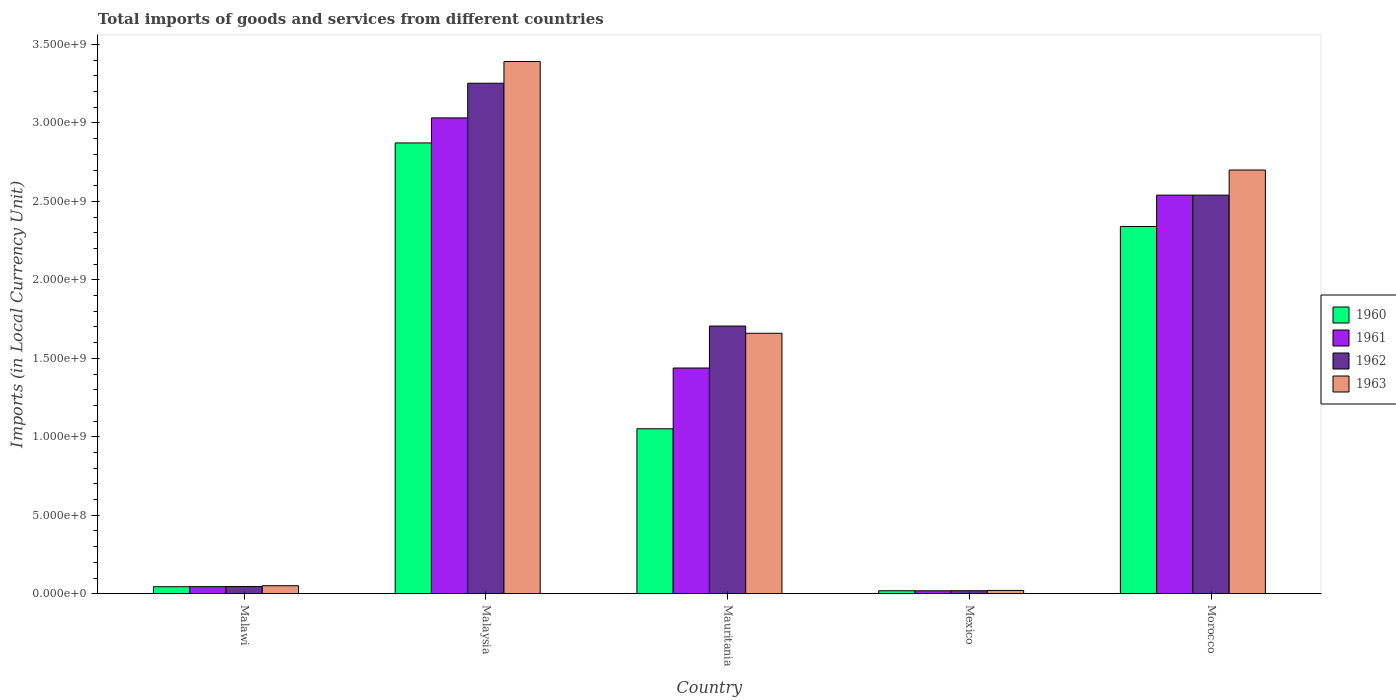What is the label of the 5th group of bars from the left?
Provide a succinct answer. Morocco. What is the Amount of goods and services imports in 1962 in Malawi?
Keep it short and to the point. 4.58e+07. Across all countries, what is the maximum Amount of goods and services imports in 1961?
Your answer should be compact. 3.03e+09. Across all countries, what is the minimum Amount of goods and services imports in 1963?
Give a very brief answer. 2.11e+07. In which country was the Amount of goods and services imports in 1960 maximum?
Your answer should be very brief. Malaysia. In which country was the Amount of goods and services imports in 1963 minimum?
Provide a succinct answer. Mexico. What is the total Amount of goods and services imports in 1960 in the graph?
Keep it short and to the point. 6.33e+09. What is the difference between the Amount of goods and services imports in 1961 in Mexico and that in Morocco?
Keep it short and to the point. -2.52e+09. What is the difference between the Amount of goods and services imports in 1960 in Malaysia and the Amount of goods and services imports in 1962 in Morocco?
Give a very brief answer. 3.33e+08. What is the average Amount of goods and services imports in 1961 per country?
Provide a succinct answer. 1.41e+09. What is the difference between the Amount of goods and services imports of/in 1961 and Amount of goods and services imports of/in 1960 in Malawi?
Keep it short and to the point. 4.00e+05. What is the ratio of the Amount of goods and services imports in 1960 in Malawi to that in Morocco?
Make the answer very short. 0.02. What is the difference between the highest and the second highest Amount of goods and services imports in 1962?
Ensure brevity in your answer.  7.13e+08. What is the difference between the highest and the lowest Amount of goods and services imports in 1963?
Ensure brevity in your answer.  3.37e+09. In how many countries, is the Amount of goods and services imports in 1960 greater than the average Amount of goods and services imports in 1960 taken over all countries?
Give a very brief answer. 2. Is the sum of the Amount of goods and services imports in 1962 in Malaysia and Morocco greater than the maximum Amount of goods and services imports in 1961 across all countries?
Offer a very short reply. Yes. Is it the case that in every country, the sum of the Amount of goods and services imports in 1960 and Amount of goods and services imports in 1963 is greater than the sum of Amount of goods and services imports in 1962 and Amount of goods and services imports in 1961?
Offer a terse response. No. What does the 1st bar from the right in Malaysia represents?
Make the answer very short. 1963. Is it the case that in every country, the sum of the Amount of goods and services imports in 1960 and Amount of goods and services imports in 1963 is greater than the Amount of goods and services imports in 1962?
Make the answer very short. Yes. Are the values on the major ticks of Y-axis written in scientific E-notation?
Keep it short and to the point. Yes. Where does the legend appear in the graph?
Give a very brief answer. Center right. How are the legend labels stacked?
Keep it short and to the point. Vertical. What is the title of the graph?
Keep it short and to the point. Total imports of goods and services from different countries. What is the label or title of the Y-axis?
Give a very brief answer. Imports (in Local Currency Unit). What is the Imports (in Local Currency Unit) of 1960 in Malawi?
Your response must be concise. 4.47e+07. What is the Imports (in Local Currency Unit) in 1961 in Malawi?
Offer a terse response. 4.51e+07. What is the Imports (in Local Currency Unit) of 1962 in Malawi?
Give a very brief answer. 4.58e+07. What is the Imports (in Local Currency Unit) of 1963 in Malawi?
Your response must be concise. 5.11e+07. What is the Imports (in Local Currency Unit) of 1960 in Malaysia?
Keep it short and to the point. 2.87e+09. What is the Imports (in Local Currency Unit) of 1961 in Malaysia?
Ensure brevity in your answer.  3.03e+09. What is the Imports (in Local Currency Unit) in 1962 in Malaysia?
Make the answer very short. 3.25e+09. What is the Imports (in Local Currency Unit) of 1963 in Malaysia?
Offer a very short reply. 3.39e+09. What is the Imports (in Local Currency Unit) of 1960 in Mauritania?
Your response must be concise. 1.05e+09. What is the Imports (in Local Currency Unit) in 1961 in Mauritania?
Make the answer very short. 1.44e+09. What is the Imports (in Local Currency Unit) in 1962 in Mauritania?
Ensure brevity in your answer.  1.71e+09. What is the Imports (in Local Currency Unit) of 1963 in Mauritania?
Offer a terse response. 1.66e+09. What is the Imports (in Local Currency Unit) in 1960 in Mexico?
Your answer should be very brief. 1.90e+07. What is the Imports (in Local Currency Unit) of 1961 in Mexico?
Your response must be concise. 1.88e+07. What is the Imports (in Local Currency Unit) in 1962 in Mexico?
Give a very brief answer. 1.92e+07. What is the Imports (in Local Currency Unit) of 1963 in Mexico?
Make the answer very short. 2.11e+07. What is the Imports (in Local Currency Unit) of 1960 in Morocco?
Give a very brief answer. 2.34e+09. What is the Imports (in Local Currency Unit) in 1961 in Morocco?
Offer a very short reply. 2.54e+09. What is the Imports (in Local Currency Unit) of 1962 in Morocco?
Provide a short and direct response. 2.54e+09. What is the Imports (in Local Currency Unit) of 1963 in Morocco?
Keep it short and to the point. 2.70e+09. Across all countries, what is the maximum Imports (in Local Currency Unit) in 1960?
Make the answer very short. 2.87e+09. Across all countries, what is the maximum Imports (in Local Currency Unit) in 1961?
Your answer should be very brief. 3.03e+09. Across all countries, what is the maximum Imports (in Local Currency Unit) in 1962?
Your answer should be compact. 3.25e+09. Across all countries, what is the maximum Imports (in Local Currency Unit) in 1963?
Your answer should be very brief. 3.39e+09. Across all countries, what is the minimum Imports (in Local Currency Unit) of 1960?
Give a very brief answer. 1.90e+07. Across all countries, what is the minimum Imports (in Local Currency Unit) of 1961?
Keep it short and to the point. 1.88e+07. Across all countries, what is the minimum Imports (in Local Currency Unit) in 1962?
Ensure brevity in your answer.  1.92e+07. Across all countries, what is the minimum Imports (in Local Currency Unit) of 1963?
Provide a short and direct response. 2.11e+07. What is the total Imports (in Local Currency Unit) in 1960 in the graph?
Your answer should be very brief. 6.33e+09. What is the total Imports (in Local Currency Unit) in 1961 in the graph?
Offer a terse response. 7.07e+09. What is the total Imports (in Local Currency Unit) of 1962 in the graph?
Ensure brevity in your answer.  7.56e+09. What is the total Imports (in Local Currency Unit) of 1963 in the graph?
Give a very brief answer. 7.82e+09. What is the difference between the Imports (in Local Currency Unit) of 1960 in Malawi and that in Malaysia?
Your response must be concise. -2.83e+09. What is the difference between the Imports (in Local Currency Unit) in 1961 in Malawi and that in Malaysia?
Provide a succinct answer. -2.99e+09. What is the difference between the Imports (in Local Currency Unit) in 1962 in Malawi and that in Malaysia?
Your answer should be compact. -3.21e+09. What is the difference between the Imports (in Local Currency Unit) of 1963 in Malawi and that in Malaysia?
Your response must be concise. -3.34e+09. What is the difference between the Imports (in Local Currency Unit) in 1960 in Malawi and that in Mauritania?
Give a very brief answer. -1.01e+09. What is the difference between the Imports (in Local Currency Unit) in 1961 in Malawi and that in Mauritania?
Offer a terse response. -1.39e+09. What is the difference between the Imports (in Local Currency Unit) of 1962 in Malawi and that in Mauritania?
Your answer should be compact. -1.66e+09. What is the difference between the Imports (in Local Currency Unit) in 1963 in Malawi and that in Mauritania?
Give a very brief answer. -1.61e+09. What is the difference between the Imports (in Local Currency Unit) of 1960 in Malawi and that in Mexico?
Make the answer very short. 2.57e+07. What is the difference between the Imports (in Local Currency Unit) of 1961 in Malawi and that in Mexico?
Provide a succinct answer. 2.63e+07. What is the difference between the Imports (in Local Currency Unit) of 1962 in Malawi and that in Mexico?
Provide a succinct answer. 2.66e+07. What is the difference between the Imports (in Local Currency Unit) in 1963 in Malawi and that in Mexico?
Your answer should be very brief. 3.00e+07. What is the difference between the Imports (in Local Currency Unit) in 1960 in Malawi and that in Morocco?
Ensure brevity in your answer.  -2.30e+09. What is the difference between the Imports (in Local Currency Unit) of 1961 in Malawi and that in Morocco?
Ensure brevity in your answer.  -2.49e+09. What is the difference between the Imports (in Local Currency Unit) of 1962 in Malawi and that in Morocco?
Provide a short and direct response. -2.49e+09. What is the difference between the Imports (in Local Currency Unit) of 1963 in Malawi and that in Morocco?
Ensure brevity in your answer.  -2.65e+09. What is the difference between the Imports (in Local Currency Unit) of 1960 in Malaysia and that in Mauritania?
Your response must be concise. 1.82e+09. What is the difference between the Imports (in Local Currency Unit) in 1961 in Malaysia and that in Mauritania?
Give a very brief answer. 1.59e+09. What is the difference between the Imports (in Local Currency Unit) in 1962 in Malaysia and that in Mauritania?
Give a very brief answer. 1.55e+09. What is the difference between the Imports (in Local Currency Unit) in 1963 in Malaysia and that in Mauritania?
Keep it short and to the point. 1.73e+09. What is the difference between the Imports (in Local Currency Unit) in 1960 in Malaysia and that in Mexico?
Offer a terse response. 2.85e+09. What is the difference between the Imports (in Local Currency Unit) in 1961 in Malaysia and that in Mexico?
Make the answer very short. 3.01e+09. What is the difference between the Imports (in Local Currency Unit) in 1962 in Malaysia and that in Mexico?
Your answer should be compact. 3.23e+09. What is the difference between the Imports (in Local Currency Unit) in 1963 in Malaysia and that in Mexico?
Offer a very short reply. 3.37e+09. What is the difference between the Imports (in Local Currency Unit) of 1960 in Malaysia and that in Morocco?
Offer a terse response. 5.33e+08. What is the difference between the Imports (in Local Currency Unit) of 1961 in Malaysia and that in Morocco?
Give a very brief answer. 4.92e+08. What is the difference between the Imports (in Local Currency Unit) of 1962 in Malaysia and that in Morocco?
Provide a succinct answer. 7.13e+08. What is the difference between the Imports (in Local Currency Unit) of 1963 in Malaysia and that in Morocco?
Your answer should be compact. 6.92e+08. What is the difference between the Imports (in Local Currency Unit) of 1960 in Mauritania and that in Mexico?
Give a very brief answer. 1.03e+09. What is the difference between the Imports (in Local Currency Unit) in 1961 in Mauritania and that in Mexico?
Provide a succinct answer. 1.42e+09. What is the difference between the Imports (in Local Currency Unit) in 1962 in Mauritania and that in Mexico?
Your response must be concise. 1.69e+09. What is the difference between the Imports (in Local Currency Unit) of 1963 in Mauritania and that in Mexico?
Offer a very short reply. 1.64e+09. What is the difference between the Imports (in Local Currency Unit) in 1960 in Mauritania and that in Morocco?
Keep it short and to the point. -1.29e+09. What is the difference between the Imports (in Local Currency Unit) of 1961 in Mauritania and that in Morocco?
Your answer should be compact. -1.10e+09. What is the difference between the Imports (in Local Currency Unit) in 1962 in Mauritania and that in Morocco?
Provide a short and direct response. -8.34e+08. What is the difference between the Imports (in Local Currency Unit) in 1963 in Mauritania and that in Morocco?
Make the answer very short. -1.04e+09. What is the difference between the Imports (in Local Currency Unit) in 1960 in Mexico and that in Morocco?
Your answer should be very brief. -2.32e+09. What is the difference between the Imports (in Local Currency Unit) of 1961 in Mexico and that in Morocco?
Offer a very short reply. -2.52e+09. What is the difference between the Imports (in Local Currency Unit) in 1962 in Mexico and that in Morocco?
Offer a terse response. -2.52e+09. What is the difference between the Imports (in Local Currency Unit) in 1963 in Mexico and that in Morocco?
Your answer should be compact. -2.68e+09. What is the difference between the Imports (in Local Currency Unit) of 1960 in Malawi and the Imports (in Local Currency Unit) of 1961 in Malaysia?
Your response must be concise. -2.99e+09. What is the difference between the Imports (in Local Currency Unit) in 1960 in Malawi and the Imports (in Local Currency Unit) in 1962 in Malaysia?
Offer a terse response. -3.21e+09. What is the difference between the Imports (in Local Currency Unit) of 1960 in Malawi and the Imports (in Local Currency Unit) of 1963 in Malaysia?
Give a very brief answer. -3.35e+09. What is the difference between the Imports (in Local Currency Unit) in 1961 in Malawi and the Imports (in Local Currency Unit) in 1962 in Malaysia?
Give a very brief answer. -3.21e+09. What is the difference between the Imports (in Local Currency Unit) of 1961 in Malawi and the Imports (in Local Currency Unit) of 1963 in Malaysia?
Your answer should be very brief. -3.35e+09. What is the difference between the Imports (in Local Currency Unit) in 1962 in Malawi and the Imports (in Local Currency Unit) in 1963 in Malaysia?
Your response must be concise. -3.35e+09. What is the difference between the Imports (in Local Currency Unit) of 1960 in Malawi and the Imports (in Local Currency Unit) of 1961 in Mauritania?
Offer a terse response. -1.39e+09. What is the difference between the Imports (in Local Currency Unit) in 1960 in Malawi and the Imports (in Local Currency Unit) in 1962 in Mauritania?
Make the answer very short. -1.66e+09. What is the difference between the Imports (in Local Currency Unit) of 1960 in Malawi and the Imports (in Local Currency Unit) of 1963 in Mauritania?
Keep it short and to the point. -1.62e+09. What is the difference between the Imports (in Local Currency Unit) in 1961 in Malawi and the Imports (in Local Currency Unit) in 1962 in Mauritania?
Offer a terse response. -1.66e+09. What is the difference between the Imports (in Local Currency Unit) of 1961 in Malawi and the Imports (in Local Currency Unit) of 1963 in Mauritania?
Keep it short and to the point. -1.61e+09. What is the difference between the Imports (in Local Currency Unit) in 1962 in Malawi and the Imports (in Local Currency Unit) in 1963 in Mauritania?
Offer a very short reply. -1.61e+09. What is the difference between the Imports (in Local Currency Unit) in 1960 in Malawi and the Imports (in Local Currency Unit) in 1961 in Mexico?
Your answer should be very brief. 2.59e+07. What is the difference between the Imports (in Local Currency Unit) in 1960 in Malawi and the Imports (in Local Currency Unit) in 1962 in Mexico?
Your answer should be very brief. 2.55e+07. What is the difference between the Imports (in Local Currency Unit) in 1960 in Malawi and the Imports (in Local Currency Unit) in 1963 in Mexico?
Keep it short and to the point. 2.36e+07. What is the difference between the Imports (in Local Currency Unit) in 1961 in Malawi and the Imports (in Local Currency Unit) in 1962 in Mexico?
Provide a succinct answer. 2.59e+07. What is the difference between the Imports (in Local Currency Unit) in 1961 in Malawi and the Imports (in Local Currency Unit) in 1963 in Mexico?
Provide a succinct answer. 2.40e+07. What is the difference between the Imports (in Local Currency Unit) of 1962 in Malawi and the Imports (in Local Currency Unit) of 1963 in Mexico?
Your response must be concise. 2.47e+07. What is the difference between the Imports (in Local Currency Unit) in 1960 in Malawi and the Imports (in Local Currency Unit) in 1961 in Morocco?
Ensure brevity in your answer.  -2.50e+09. What is the difference between the Imports (in Local Currency Unit) of 1960 in Malawi and the Imports (in Local Currency Unit) of 1962 in Morocco?
Provide a succinct answer. -2.50e+09. What is the difference between the Imports (in Local Currency Unit) of 1960 in Malawi and the Imports (in Local Currency Unit) of 1963 in Morocco?
Offer a very short reply. -2.66e+09. What is the difference between the Imports (in Local Currency Unit) in 1961 in Malawi and the Imports (in Local Currency Unit) in 1962 in Morocco?
Offer a very short reply. -2.49e+09. What is the difference between the Imports (in Local Currency Unit) of 1961 in Malawi and the Imports (in Local Currency Unit) of 1963 in Morocco?
Give a very brief answer. -2.65e+09. What is the difference between the Imports (in Local Currency Unit) in 1962 in Malawi and the Imports (in Local Currency Unit) in 1963 in Morocco?
Provide a succinct answer. -2.65e+09. What is the difference between the Imports (in Local Currency Unit) of 1960 in Malaysia and the Imports (in Local Currency Unit) of 1961 in Mauritania?
Offer a very short reply. 1.43e+09. What is the difference between the Imports (in Local Currency Unit) of 1960 in Malaysia and the Imports (in Local Currency Unit) of 1962 in Mauritania?
Make the answer very short. 1.17e+09. What is the difference between the Imports (in Local Currency Unit) of 1960 in Malaysia and the Imports (in Local Currency Unit) of 1963 in Mauritania?
Offer a terse response. 1.21e+09. What is the difference between the Imports (in Local Currency Unit) of 1961 in Malaysia and the Imports (in Local Currency Unit) of 1962 in Mauritania?
Ensure brevity in your answer.  1.33e+09. What is the difference between the Imports (in Local Currency Unit) in 1961 in Malaysia and the Imports (in Local Currency Unit) in 1963 in Mauritania?
Your response must be concise. 1.37e+09. What is the difference between the Imports (in Local Currency Unit) of 1962 in Malaysia and the Imports (in Local Currency Unit) of 1963 in Mauritania?
Your answer should be compact. 1.59e+09. What is the difference between the Imports (in Local Currency Unit) of 1960 in Malaysia and the Imports (in Local Currency Unit) of 1961 in Mexico?
Your answer should be compact. 2.85e+09. What is the difference between the Imports (in Local Currency Unit) in 1960 in Malaysia and the Imports (in Local Currency Unit) in 1962 in Mexico?
Offer a very short reply. 2.85e+09. What is the difference between the Imports (in Local Currency Unit) of 1960 in Malaysia and the Imports (in Local Currency Unit) of 1963 in Mexico?
Keep it short and to the point. 2.85e+09. What is the difference between the Imports (in Local Currency Unit) of 1961 in Malaysia and the Imports (in Local Currency Unit) of 1962 in Mexico?
Offer a terse response. 3.01e+09. What is the difference between the Imports (in Local Currency Unit) of 1961 in Malaysia and the Imports (in Local Currency Unit) of 1963 in Mexico?
Make the answer very short. 3.01e+09. What is the difference between the Imports (in Local Currency Unit) of 1962 in Malaysia and the Imports (in Local Currency Unit) of 1963 in Mexico?
Give a very brief answer. 3.23e+09. What is the difference between the Imports (in Local Currency Unit) of 1960 in Malaysia and the Imports (in Local Currency Unit) of 1961 in Morocco?
Offer a very short reply. 3.33e+08. What is the difference between the Imports (in Local Currency Unit) in 1960 in Malaysia and the Imports (in Local Currency Unit) in 1962 in Morocco?
Your answer should be compact. 3.33e+08. What is the difference between the Imports (in Local Currency Unit) in 1960 in Malaysia and the Imports (in Local Currency Unit) in 1963 in Morocco?
Ensure brevity in your answer.  1.73e+08. What is the difference between the Imports (in Local Currency Unit) of 1961 in Malaysia and the Imports (in Local Currency Unit) of 1962 in Morocco?
Offer a very short reply. 4.92e+08. What is the difference between the Imports (in Local Currency Unit) of 1961 in Malaysia and the Imports (in Local Currency Unit) of 1963 in Morocco?
Provide a short and direct response. 3.32e+08. What is the difference between the Imports (in Local Currency Unit) in 1962 in Malaysia and the Imports (in Local Currency Unit) in 1963 in Morocco?
Make the answer very short. 5.53e+08. What is the difference between the Imports (in Local Currency Unit) in 1960 in Mauritania and the Imports (in Local Currency Unit) in 1961 in Mexico?
Your answer should be compact. 1.03e+09. What is the difference between the Imports (in Local Currency Unit) of 1960 in Mauritania and the Imports (in Local Currency Unit) of 1962 in Mexico?
Provide a succinct answer. 1.03e+09. What is the difference between the Imports (in Local Currency Unit) in 1960 in Mauritania and the Imports (in Local Currency Unit) in 1963 in Mexico?
Make the answer very short. 1.03e+09. What is the difference between the Imports (in Local Currency Unit) in 1961 in Mauritania and the Imports (in Local Currency Unit) in 1962 in Mexico?
Keep it short and to the point. 1.42e+09. What is the difference between the Imports (in Local Currency Unit) in 1961 in Mauritania and the Imports (in Local Currency Unit) in 1963 in Mexico?
Ensure brevity in your answer.  1.42e+09. What is the difference between the Imports (in Local Currency Unit) in 1962 in Mauritania and the Imports (in Local Currency Unit) in 1963 in Mexico?
Your answer should be compact. 1.68e+09. What is the difference between the Imports (in Local Currency Unit) in 1960 in Mauritania and the Imports (in Local Currency Unit) in 1961 in Morocco?
Ensure brevity in your answer.  -1.49e+09. What is the difference between the Imports (in Local Currency Unit) in 1960 in Mauritania and the Imports (in Local Currency Unit) in 1962 in Morocco?
Make the answer very short. -1.49e+09. What is the difference between the Imports (in Local Currency Unit) in 1960 in Mauritania and the Imports (in Local Currency Unit) in 1963 in Morocco?
Ensure brevity in your answer.  -1.65e+09. What is the difference between the Imports (in Local Currency Unit) in 1961 in Mauritania and the Imports (in Local Currency Unit) in 1962 in Morocco?
Provide a succinct answer. -1.10e+09. What is the difference between the Imports (in Local Currency Unit) of 1961 in Mauritania and the Imports (in Local Currency Unit) of 1963 in Morocco?
Provide a short and direct response. -1.26e+09. What is the difference between the Imports (in Local Currency Unit) of 1962 in Mauritania and the Imports (in Local Currency Unit) of 1963 in Morocco?
Provide a succinct answer. -9.94e+08. What is the difference between the Imports (in Local Currency Unit) of 1960 in Mexico and the Imports (in Local Currency Unit) of 1961 in Morocco?
Make the answer very short. -2.52e+09. What is the difference between the Imports (in Local Currency Unit) in 1960 in Mexico and the Imports (in Local Currency Unit) in 1962 in Morocco?
Offer a terse response. -2.52e+09. What is the difference between the Imports (in Local Currency Unit) in 1960 in Mexico and the Imports (in Local Currency Unit) in 1963 in Morocco?
Ensure brevity in your answer.  -2.68e+09. What is the difference between the Imports (in Local Currency Unit) in 1961 in Mexico and the Imports (in Local Currency Unit) in 1962 in Morocco?
Keep it short and to the point. -2.52e+09. What is the difference between the Imports (in Local Currency Unit) in 1961 in Mexico and the Imports (in Local Currency Unit) in 1963 in Morocco?
Give a very brief answer. -2.68e+09. What is the difference between the Imports (in Local Currency Unit) in 1962 in Mexico and the Imports (in Local Currency Unit) in 1963 in Morocco?
Your answer should be very brief. -2.68e+09. What is the average Imports (in Local Currency Unit) in 1960 per country?
Ensure brevity in your answer.  1.27e+09. What is the average Imports (in Local Currency Unit) of 1961 per country?
Ensure brevity in your answer.  1.41e+09. What is the average Imports (in Local Currency Unit) in 1962 per country?
Keep it short and to the point. 1.51e+09. What is the average Imports (in Local Currency Unit) in 1963 per country?
Your response must be concise. 1.56e+09. What is the difference between the Imports (in Local Currency Unit) in 1960 and Imports (in Local Currency Unit) in 1961 in Malawi?
Provide a succinct answer. -4.00e+05. What is the difference between the Imports (in Local Currency Unit) in 1960 and Imports (in Local Currency Unit) in 1962 in Malawi?
Your answer should be very brief. -1.10e+06. What is the difference between the Imports (in Local Currency Unit) of 1960 and Imports (in Local Currency Unit) of 1963 in Malawi?
Provide a short and direct response. -6.40e+06. What is the difference between the Imports (in Local Currency Unit) of 1961 and Imports (in Local Currency Unit) of 1962 in Malawi?
Give a very brief answer. -7.00e+05. What is the difference between the Imports (in Local Currency Unit) of 1961 and Imports (in Local Currency Unit) of 1963 in Malawi?
Give a very brief answer. -6.00e+06. What is the difference between the Imports (in Local Currency Unit) in 1962 and Imports (in Local Currency Unit) in 1963 in Malawi?
Your response must be concise. -5.30e+06. What is the difference between the Imports (in Local Currency Unit) of 1960 and Imports (in Local Currency Unit) of 1961 in Malaysia?
Your answer should be very brief. -1.60e+08. What is the difference between the Imports (in Local Currency Unit) in 1960 and Imports (in Local Currency Unit) in 1962 in Malaysia?
Ensure brevity in your answer.  -3.81e+08. What is the difference between the Imports (in Local Currency Unit) of 1960 and Imports (in Local Currency Unit) of 1963 in Malaysia?
Provide a succinct answer. -5.19e+08. What is the difference between the Imports (in Local Currency Unit) of 1961 and Imports (in Local Currency Unit) of 1962 in Malaysia?
Make the answer very short. -2.21e+08. What is the difference between the Imports (in Local Currency Unit) in 1961 and Imports (in Local Currency Unit) in 1963 in Malaysia?
Ensure brevity in your answer.  -3.59e+08. What is the difference between the Imports (in Local Currency Unit) of 1962 and Imports (in Local Currency Unit) of 1963 in Malaysia?
Offer a very short reply. -1.39e+08. What is the difference between the Imports (in Local Currency Unit) in 1960 and Imports (in Local Currency Unit) in 1961 in Mauritania?
Keep it short and to the point. -3.87e+08. What is the difference between the Imports (in Local Currency Unit) in 1960 and Imports (in Local Currency Unit) in 1962 in Mauritania?
Keep it short and to the point. -6.55e+08. What is the difference between the Imports (in Local Currency Unit) of 1960 and Imports (in Local Currency Unit) of 1963 in Mauritania?
Provide a succinct answer. -6.09e+08. What is the difference between the Imports (in Local Currency Unit) of 1961 and Imports (in Local Currency Unit) of 1962 in Mauritania?
Your answer should be very brief. -2.67e+08. What is the difference between the Imports (in Local Currency Unit) in 1961 and Imports (in Local Currency Unit) in 1963 in Mauritania?
Keep it short and to the point. -2.21e+08. What is the difference between the Imports (in Local Currency Unit) in 1962 and Imports (in Local Currency Unit) in 1963 in Mauritania?
Ensure brevity in your answer.  4.61e+07. What is the difference between the Imports (in Local Currency Unit) of 1960 and Imports (in Local Currency Unit) of 1961 in Mexico?
Offer a terse response. 2.23e+05. What is the difference between the Imports (in Local Currency Unit) of 1960 and Imports (in Local Currency Unit) of 1962 in Mexico?
Give a very brief answer. -1.95e+05. What is the difference between the Imports (in Local Currency Unit) in 1960 and Imports (in Local Currency Unit) in 1963 in Mexico?
Keep it short and to the point. -2.09e+06. What is the difference between the Imports (in Local Currency Unit) of 1961 and Imports (in Local Currency Unit) of 1962 in Mexico?
Give a very brief answer. -4.18e+05. What is the difference between the Imports (in Local Currency Unit) in 1961 and Imports (in Local Currency Unit) in 1963 in Mexico?
Your answer should be very brief. -2.31e+06. What is the difference between the Imports (in Local Currency Unit) in 1962 and Imports (in Local Currency Unit) in 1963 in Mexico?
Give a very brief answer. -1.90e+06. What is the difference between the Imports (in Local Currency Unit) of 1960 and Imports (in Local Currency Unit) of 1961 in Morocco?
Offer a terse response. -2.00e+08. What is the difference between the Imports (in Local Currency Unit) in 1960 and Imports (in Local Currency Unit) in 1962 in Morocco?
Provide a succinct answer. -2.00e+08. What is the difference between the Imports (in Local Currency Unit) in 1960 and Imports (in Local Currency Unit) in 1963 in Morocco?
Make the answer very short. -3.60e+08. What is the difference between the Imports (in Local Currency Unit) in 1961 and Imports (in Local Currency Unit) in 1962 in Morocco?
Give a very brief answer. 0. What is the difference between the Imports (in Local Currency Unit) in 1961 and Imports (in Local Currency Unit) in 1963 in Morocco?
Your answer should be very brief. -1.60e+08. What is the difference between the Imports (in Local Currency Unit) of 1962 and Imports (in Local Currency Unit) of 1963 in Morocco?
Offer a terse response. -1.60e+08. What is the ratio of the Imports (in Local Currency Unit) in 1960 in Malawi to that in Malaysia?
Keep it short and to the point. 0.02. What is the ratio of the Imports (in Local Currency Unit) of 1961 in Malawi to that in Malaysia?
Provide a succinct answer. 0.01. What is the ratio of the Imports (in Local Currency Unit) in 1962 in Malawi to that in Malaysia?
Give a very brief answer. 0.01. What is the ratio of the Imports (in Local Currency Unit) of 1963 in Malawi to that in Malaysia?
Ensure brevity in your answer.  0.02. What is the ratio of the Imports (in Local Currency Unit) in 1960 in Malawi to that in Mauritania?
Offer a terse response. 0.04. What is the ratio of the Imports (in Local Currency Unit) in 1961 in Malawi to that in Mauritania?
Provide a short and direct response. 0.03. What is the ratio of the Imports (in Local Currency Unit) of 1962 in Malawi to that in Mauritania?
Make the answer very short. 0.03. What is the ratio of the Imports (in Local Currency Unit) in 1963 in Malawi to that in Mauritania?
Offer a terse response. 0.03. What is the ratio of the Imports (in Local Currency Unit) of 1960 in Malawi to that in Mexico?
Ensure brevity in your answer.  2.35. What is the ratio of the Imports (in Local Currency Unit) in 1961 in Malawi to that in Mexico?
Your answer should be very brief. 2.4. What is the ratio of the Imports (in Local Currency Unit) in 1962 in Malawi to that in Mexico?
Keep it short and to the point. 2.38. What is the ratio of the Imports (in Local Currency Unit) of 1963 in Malawi to that in Mexico?
Your answer should be compact. 2.42. What is the ratio of the Imports (in Local Currency Unit) of 1960 in Malawi to that in Morocco?
Provide a short and direct response. 0.02. What is the ratio of the Imports (in Local Currency Unit) of 1961 in Malawi to that in Morocco?
Your response must be concise. 0.02. What is the ratio of the Imports (in Local Currency Unit) of 1962 in Malawi to that in Morocco?
Your response must be concise. 0.02. What is the ratio of the Imports (in Local Currency Unit) in 1963 in Malawi to that in Morocco?
Offer a very short reply. 0.02. What is the ratio of the Imports (in Local Currency Unit) in 1960 in Malaysia to that in Mauritania?
Give a very brief answer. 2.73. What is the ratio of the Imports (in Local Currency Unit) of 1961 in Malaysia to that in Mauritania?
Offer a terse response. 2.11. What is the ratio of the Imports (in Local Currency Unit) in 1962 in Malaysia to that in Mauritania?
Your response must be concise. 1.91. What is the ratio of the Imports (in Local Currency Unit) of 1963 in Malaysia to that in Mauritania?
Provide a succinct answer. 2.04. What is the ratio of the Imports (in Local Currency Unit) in 1960 in Malaysia to that in Mexico?
Offer a terse response. 151.09. What is the ratio of the Imports (in Local Currency Unit) of 1961 in Malaysia to that in Mexico?
Your response must be concise. 161.38. What is the ratio of the Imports (in Local Currency Unit) of 1962 in Malaysia to that in Mexico?
Give a very brief answer. 169.37. What is the ratio of the Imports (in Local Currency Unit) in 1963 in Malaysia to that in Mexico?
Offer a very short reply. 160.73. What is the ratio of the Imports (in Local Currency Unit) in 1960 in Malaysia to that in Morocco?
Provide a short and direct response. 1.23. What is the ratio of the Imports (in Local Currency Unit) of 1961 in Malaysia to that in Morocco?
Provide a succinct answer. 1.19. What is the ratio of the Imports (in Local Currency Unit) of 1962 in Malaysia to that in Morocco?
Offer a very short reply. 1.28. What is the ratio of the Imports (in Local Currency Unit) of 1963 in Malaysia to that in Morocco?
Offer a terse response. 1.26. What is the ratio of the Imports (in Local Currency Unit) in 1960 in Mauritania to that in Mexico?
Provide a succinct answer. 55.29. What is the ratio of the Imports (in Local Currency Unit) of 1961 in Mauritania to that in Mexico?
Your answer should be compact. 76.56. What is the ratio of the Imports (in Local Currency Unit) in 1962 in Mauritania to that in Mexico?
Ensure brevity in your answer.  88.82. What is the ratio of the Imports (in Local Currency Unit) of 1963 in Mauritania to that in Mexico?
Your answer should be compact. 78.66. What is the ratio of the Imports (in Local Currency Unit) in 1960 in Mauritania to that in Morocco?
Provide a short and direct response. 0.45. What is the ratio of the Imports (in Local Currency Unit) of 1961 in Mauritania to that in Morocco?
Your answer should be compact. 0.57. What is the ratio of the Imports (in Local Currency Unit) in 1962 in Mauritania to that in Morocco?
Offer a terse response. 0.67. What is the ratio of the Imports (in Local Currency Unit) of 1963 in Mauritania to that in Morocco?
Your answer should be compact. 0.61. What is the ratio of the Imports (in Local Currency Unit) of 1960 in Mexico to that in Morocco?
Provide a succinct answer. 0.01. What is the ratio of the Imports (in Local Currency Unit) in 1961 in Mexico to that in Morocco?
Offer a very short reply. 0.01. What is the ratio of the Imports (in Local Currency Unit) in 1962 in Mexico to that in Morocco?
Keep it short and to the point. 0.01. What is the ratio of the Imports (in Local Currency Unit) in 1963 in Mexico to that in Morocco?
Ensure brevity in your answer.  0.01. What is the difference between the highest and the second highest Imports (in Local Currency Unit) in 1960?
Ensure brevity in your answer.  5.33e+08. What is the difference between the highest and the second highest Imports (in Local Currency Unit) of 1961?
Make the answer very short. 4.92e+08. What is the difference between the highest and the second highest Imports (in Local Currency Unit) of 1962?
Provide a succinct answer. 7.13e+08. What is the difference between the highest and the second highest Imports (in Local Currency Unit) in 1963?
Keep it short and to the point. 6.92e+08. What is the difference between the highest and the lowest Imports (in Local Currency Unit) of 1960?
Offer a terse response. 2.85e+09. What is the difference between the highest and the lowest Imports (in Local Currency Unit) of 1961?
Give a very brief answer. 3.01e+09. What is the difference between the highest and the lowest Imports (in Local Currency Unit) of 1962?
Make the answer very short. 3.23e+09. What is the difference between the highest and the lowest Imports (in Local Currency Unit) of 1963?
Your answer should be compact. 3.37e+09. 